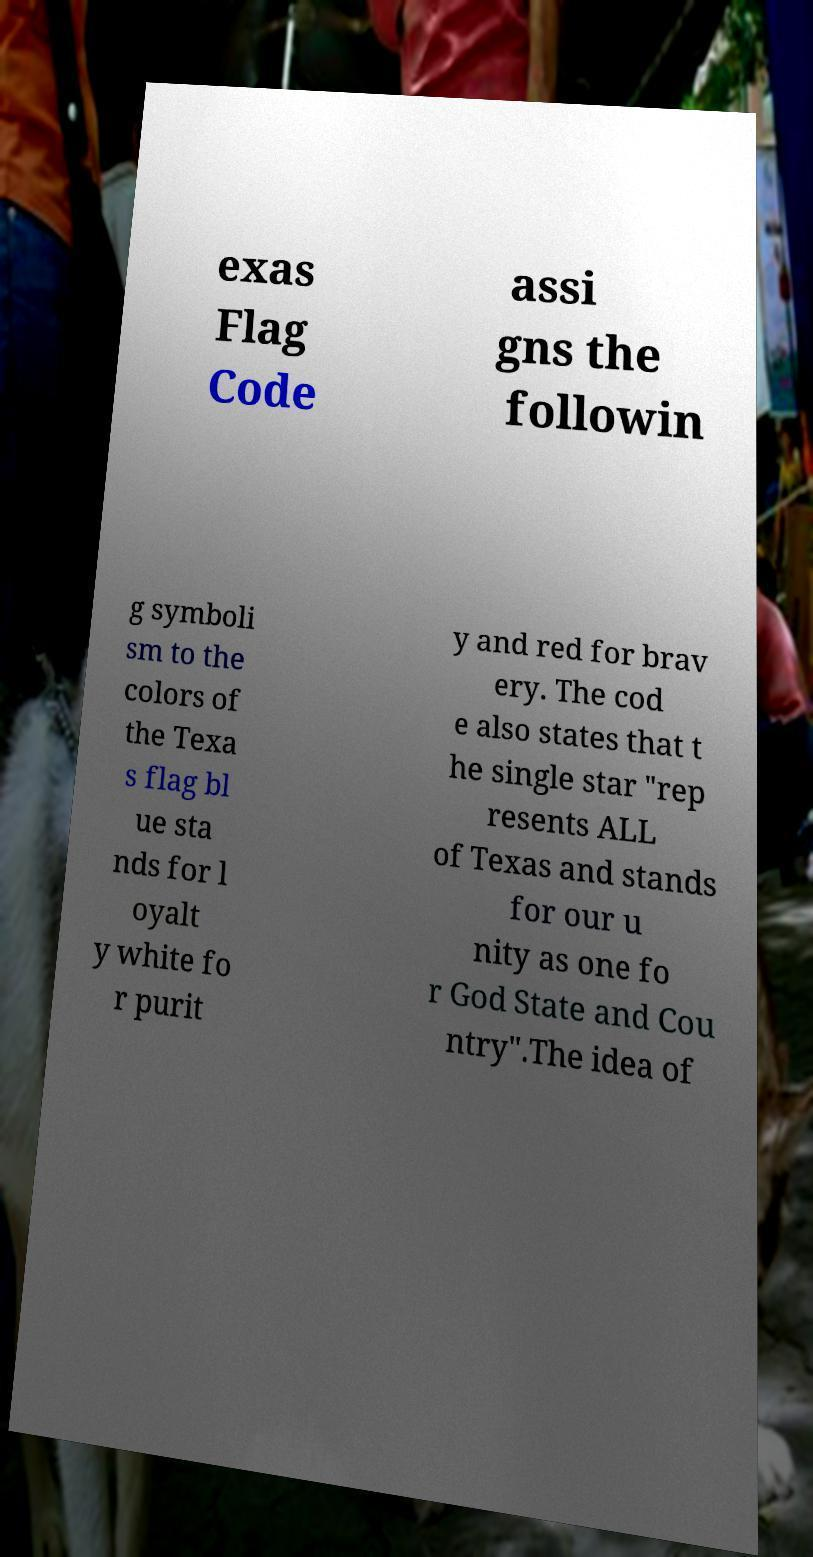Could you extract and type out the text from this image? exas Flag Code assi gns the followin g symboli sm to the colors of the Texa s flag bl ue sta nds for l oyalt y white fo r purit y and red for brav ery. The cod e also states that t he single star "rep resents ALL of Texas and stands for our u nity as one fo r God State and Cou ntry".The idea of 